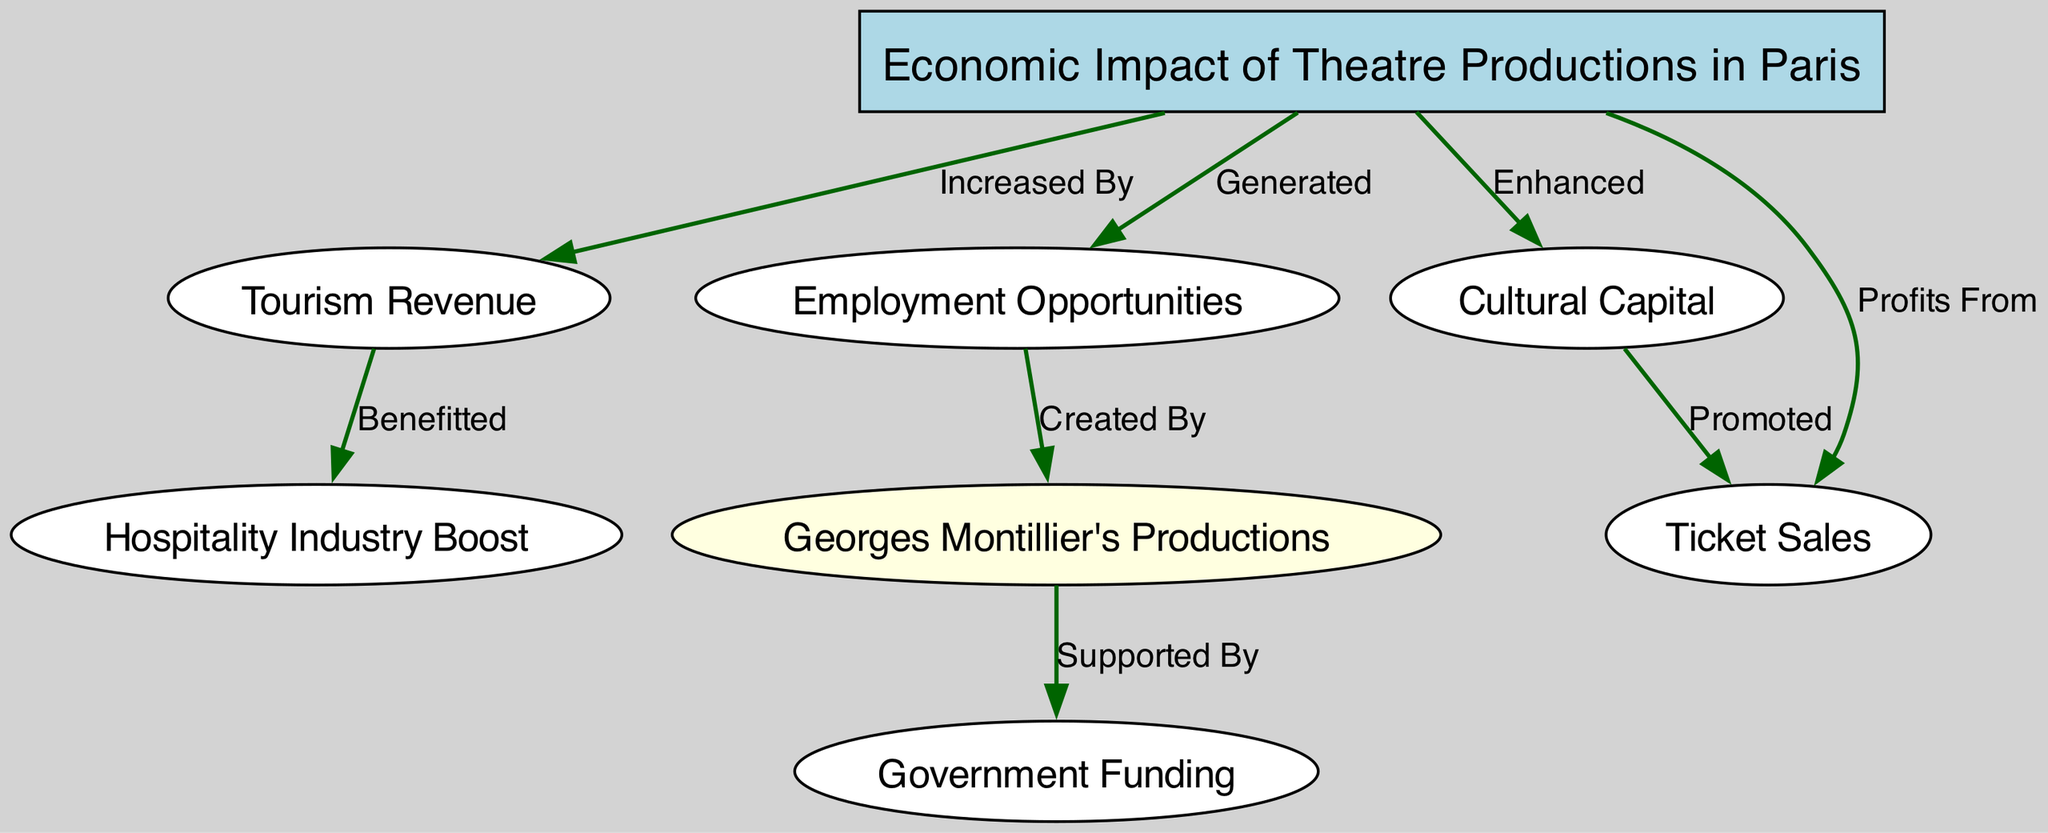What is the main topic of the diagram? The diagram focuses on "Economic Impact of Theatre Productions in Paris". This is stated explicitly as the label of the main node at the top of the diagram.
Answer: Economic Impact of Theatre Productions in Paris How many nodes are in the diagram? By counting the number of unique entities represented in the graph, we see there are eight nodes connecting various aspects related to the economic impact of theatre productions.
Answer: 8 What does the economic impact increase according to the diagram? The edge from the main topic node to the tourism revenue node indicates that the economic impact of theatre productions in Paris increases tourism revenue.
Answer: Tourism Revenue Which aspect benefits the hospitality industry? According to the diagram, the hospitality industry is boosted due to increased tourism revenue as indicated by the edge connecting these two nodes.
Answer: Hospitality Industry Boost How is employment generated according to the diagram? The node for employment opportunities is generated as a direct result of Georges Montillier's productions, shown through the link connecting these two nodes.
Answer: Created By What supports Georges Montillier's productions? The diagram indicates that Georges Montillier's productions are supported by government funding, as shown by the directed edge from the Montillier node to the government funding node.
Answer: Supported By What does the cultural capital enhance? The cultural capital node enhances ticket sales, which is indicated by the directed edge between the cultural capital and ticket sales nodes in the diagram.
Answer: Promoted Which component has a direct profit relationship with the economic impact? The diagram indicates profits from ticket sales and shows a direct relationship by the edge pointing from the main topic node to the ticket sales node.
Answer: Ticket Sales 